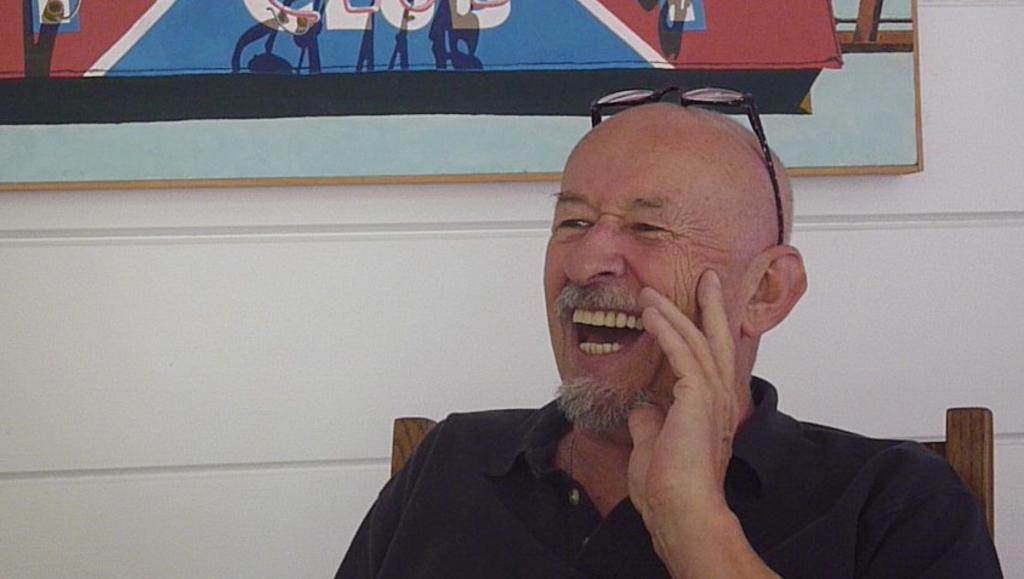What is the person in the image doing? The person is sitting in the image. What color is the shirt the person is wearing? The person is wearing a black color shirt. What can be seen on the wall in the background of the image? There is a frame attached to the wall in the background of the image. What color is the wall in the image? The wall is in white color. Can you see a rabbit whistling in the image? There is no rabbit or whistling activity present in the image. 